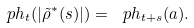<formula> <loc_0><loc_0><loc_500><loc_500>\ p h _ { t } ( | \tilde { \rho } ^ { * } ( s ) | ) = \ p h _ { t + s } ( a ) .</formula> 